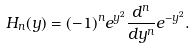Convert formula to latex. <formula><loc_0><loc_0><loc_500><loc_500>H _ { n } ( y ) = ( - 1 ) ^ { n } e ^ { y ^ { 2 } } \frac { d ^ { n } } { d y ^ { n } } e ^ { - y ^ { 2 } } .</formula> 